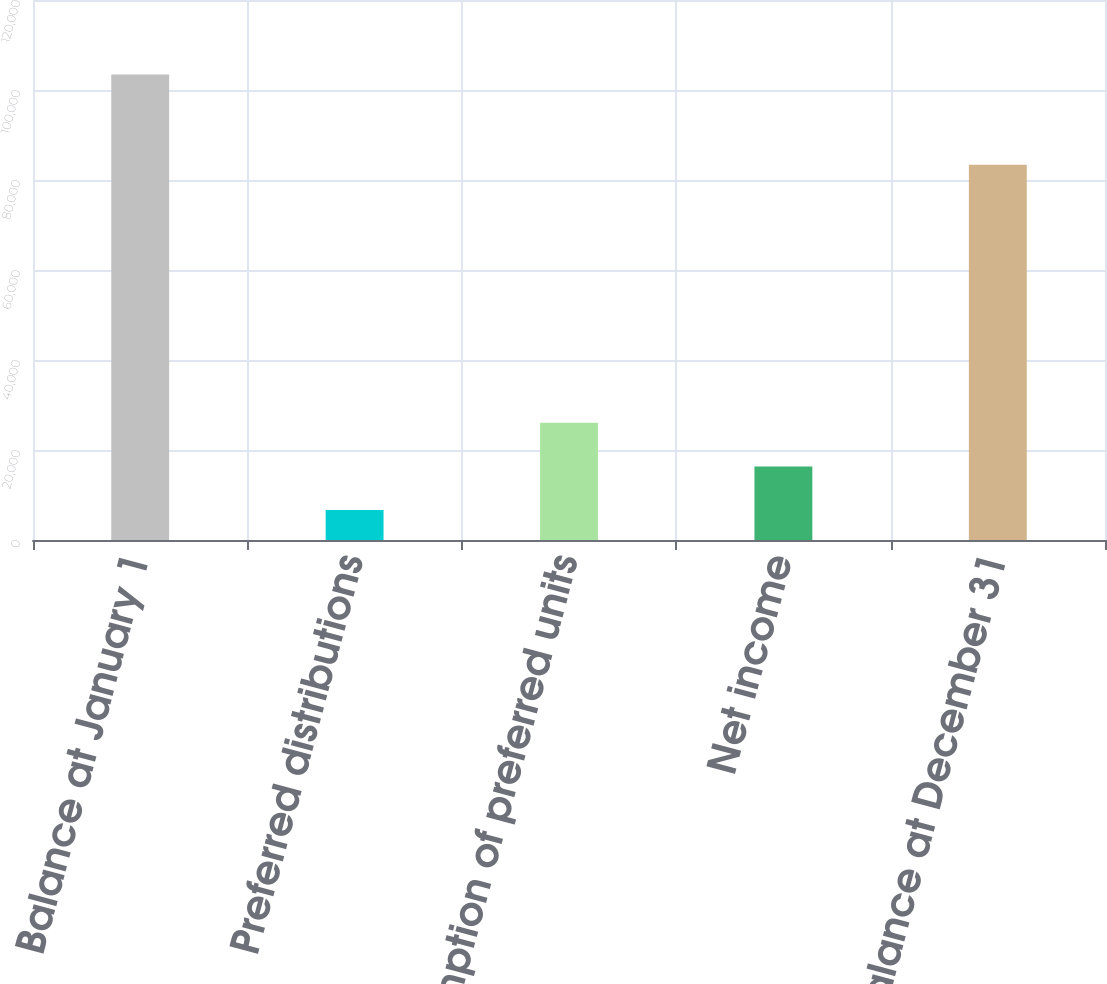Convert chart. <chart><loc_0><loc_0><loc_500><loc_500><bar_chart><fcel>Balance at January 1<fcel>Preferred distributions<fcel>Redemption of preferred units<fcel>Net income<fcel>Balance at December 31<nl><fcel>103428<fcel>6683<fcel>26032<fcel>16357.5<fcel>83384<nl></chart> 